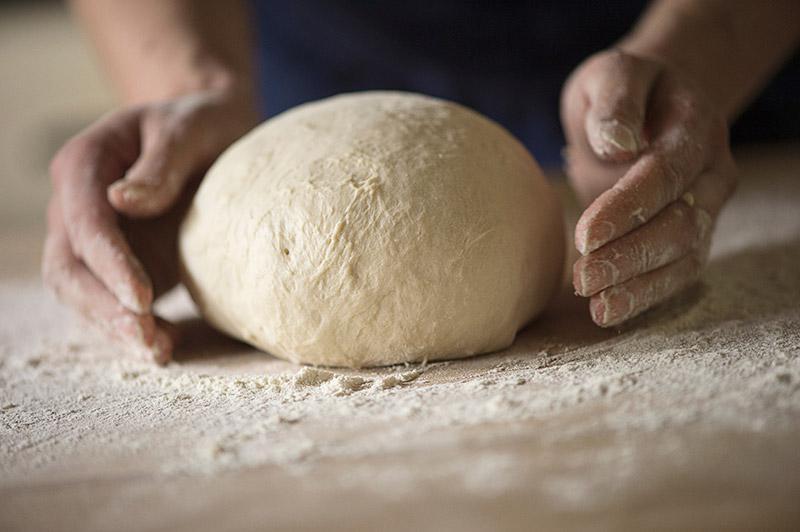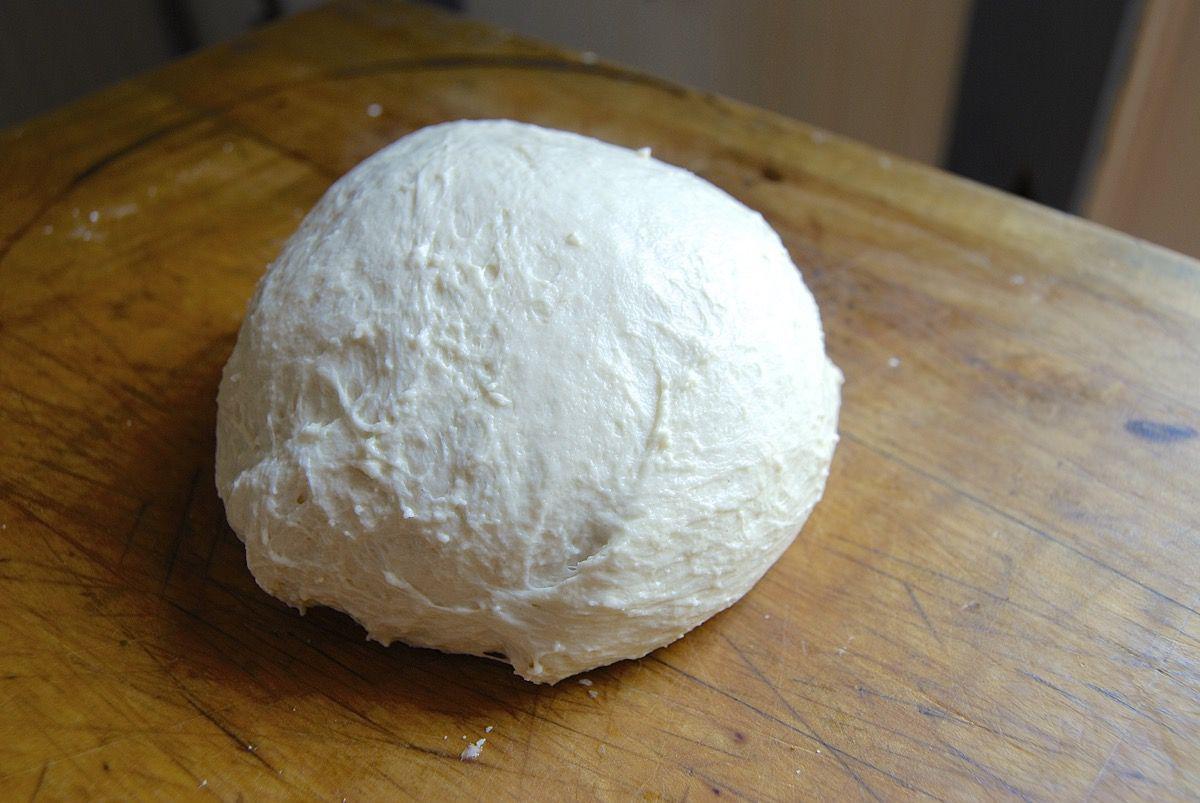The first image is the image on the left, the second image is the image on the right. Assess this claim about the two images: "At least 2 globs of dough have been baked into crusty bread.". Correct or not? Answer yes or no. No. The first image is the image on the left, the second image is the image on the right. Assess this claim about the two images: "Each image contains exactly one rounded pale-colored raw dough ball, and one of the images features a dough ball on a wood surface dusted with flour.". Correct or not? Answer yes or no. Yes. 